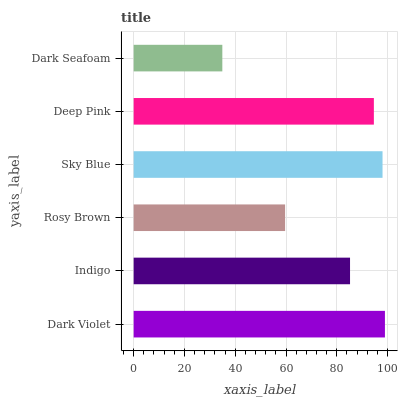Is Dark Seafoam the minimum?
Answer yes or no. Yes. Is Dark Violet the maximum?
Answer yes or no. Yes. Is Indigo the minimum?
Answer yes or no. No. Is Indigo the maximum?
Answer yes or no. No. Is Dark Violet greater than Indigo?
Answer yes or no. Yes. Is Indigo less than Dark Violet?
Answer yes or no. Yes. Is Indigo greater than Dark Violet?
Answer yes or no. No. Is Dark Violet less than Indigo?
Answer yes or no. No. Is Deep Pink the high median?
Answer yes or no. Yes. Is Indigo the low median?
Answer yes or no. Yes. Is Indigo the high median?
Answer yes or no. No. Is Rosy Brown the low median?
Answer yes or no. No. 